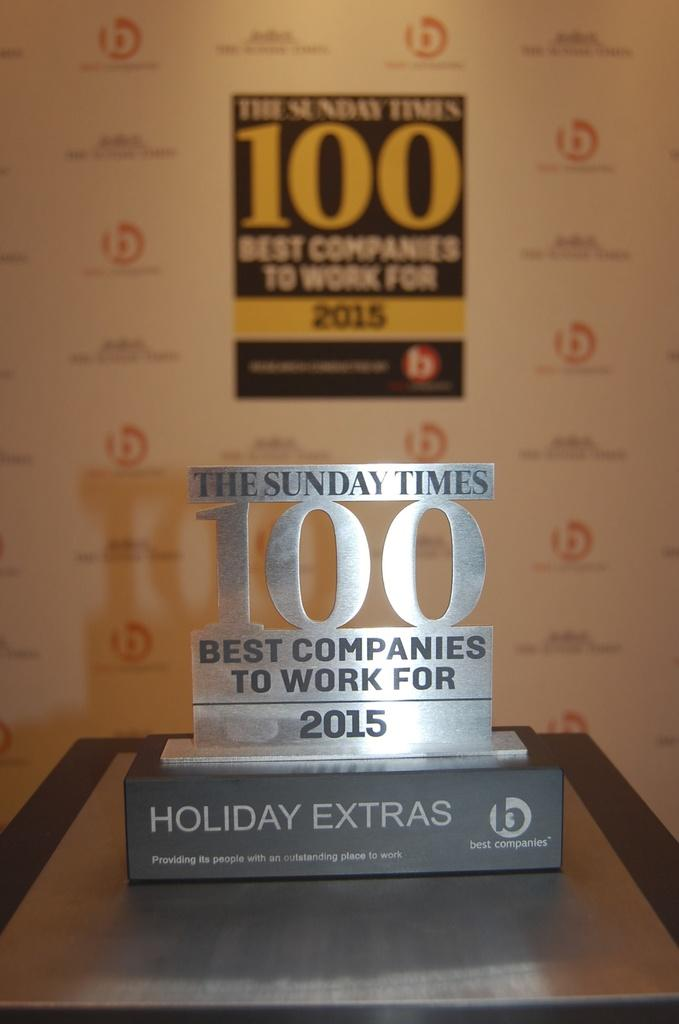<image>
Create a compact narrative representing the image presented. The award is for being one of the best companies to work for in 2015. 